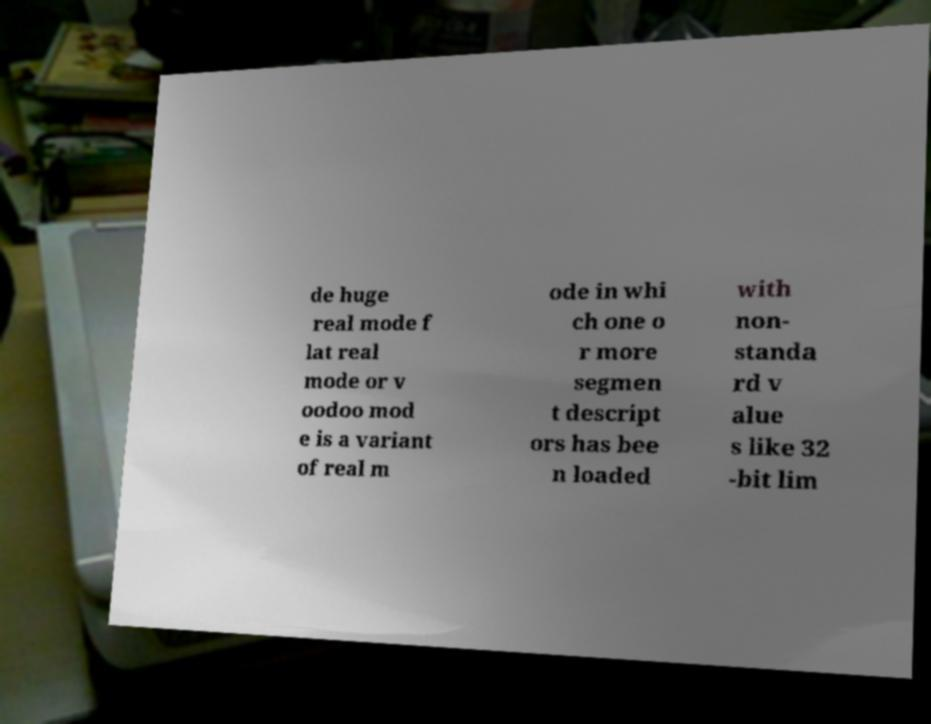Can you accurately transcribe the text from the provided image for me? de huge real mode f lat real mode or v oodoo mod e is a variant of real m ode in whi ch one o r more segmen t descript ors has bee n loaded with non- standa rd v alue s like 32 -bit lim 